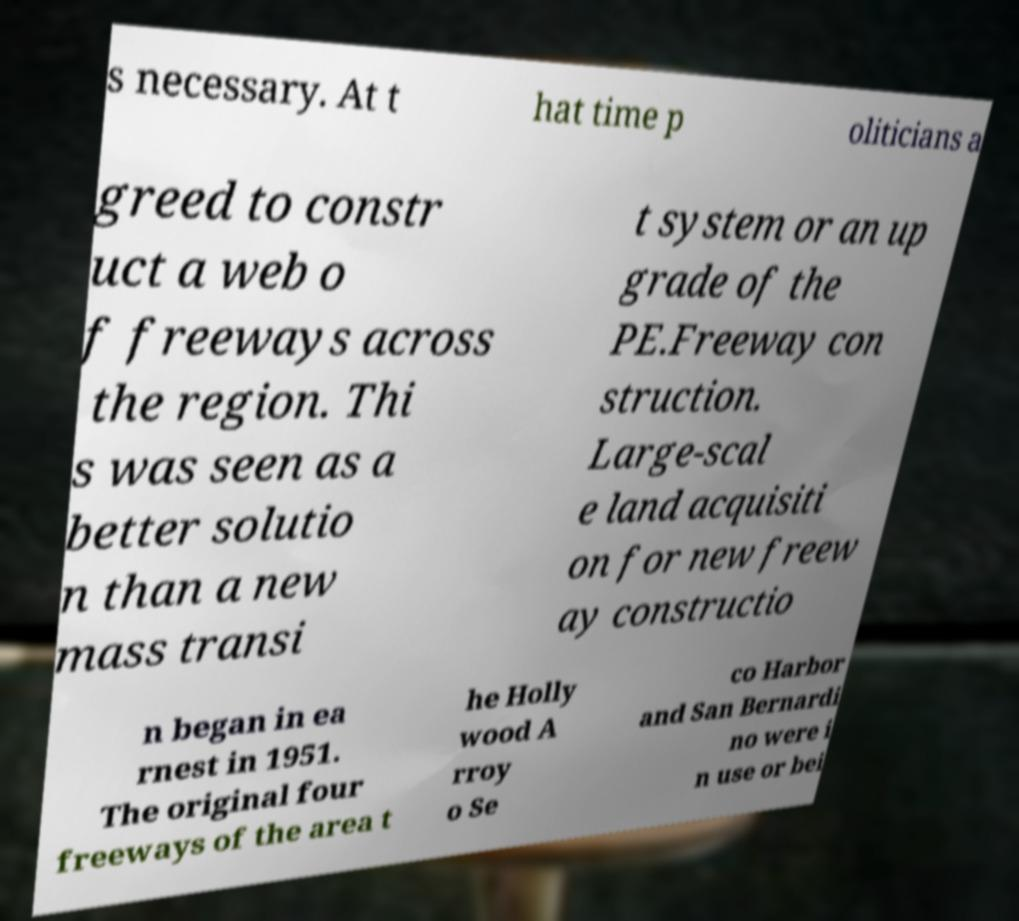What messages or text are displayed in this image? I need them in a readable, typed format. s necessary. At t hat time p oliticians a greed to constr uct a web o f freeways across the region. Thi s was seen as a better solutio n than a new mass transi t system or an up grade of the PE.Freeway con struction. Large-scal e land acquisiti on for new freew ay constructio n began in ea rnest in 1951. The original four freeways of the area t he Holly wood A rroy o Se co Harbor and San Bernardi no were i n use or bei 